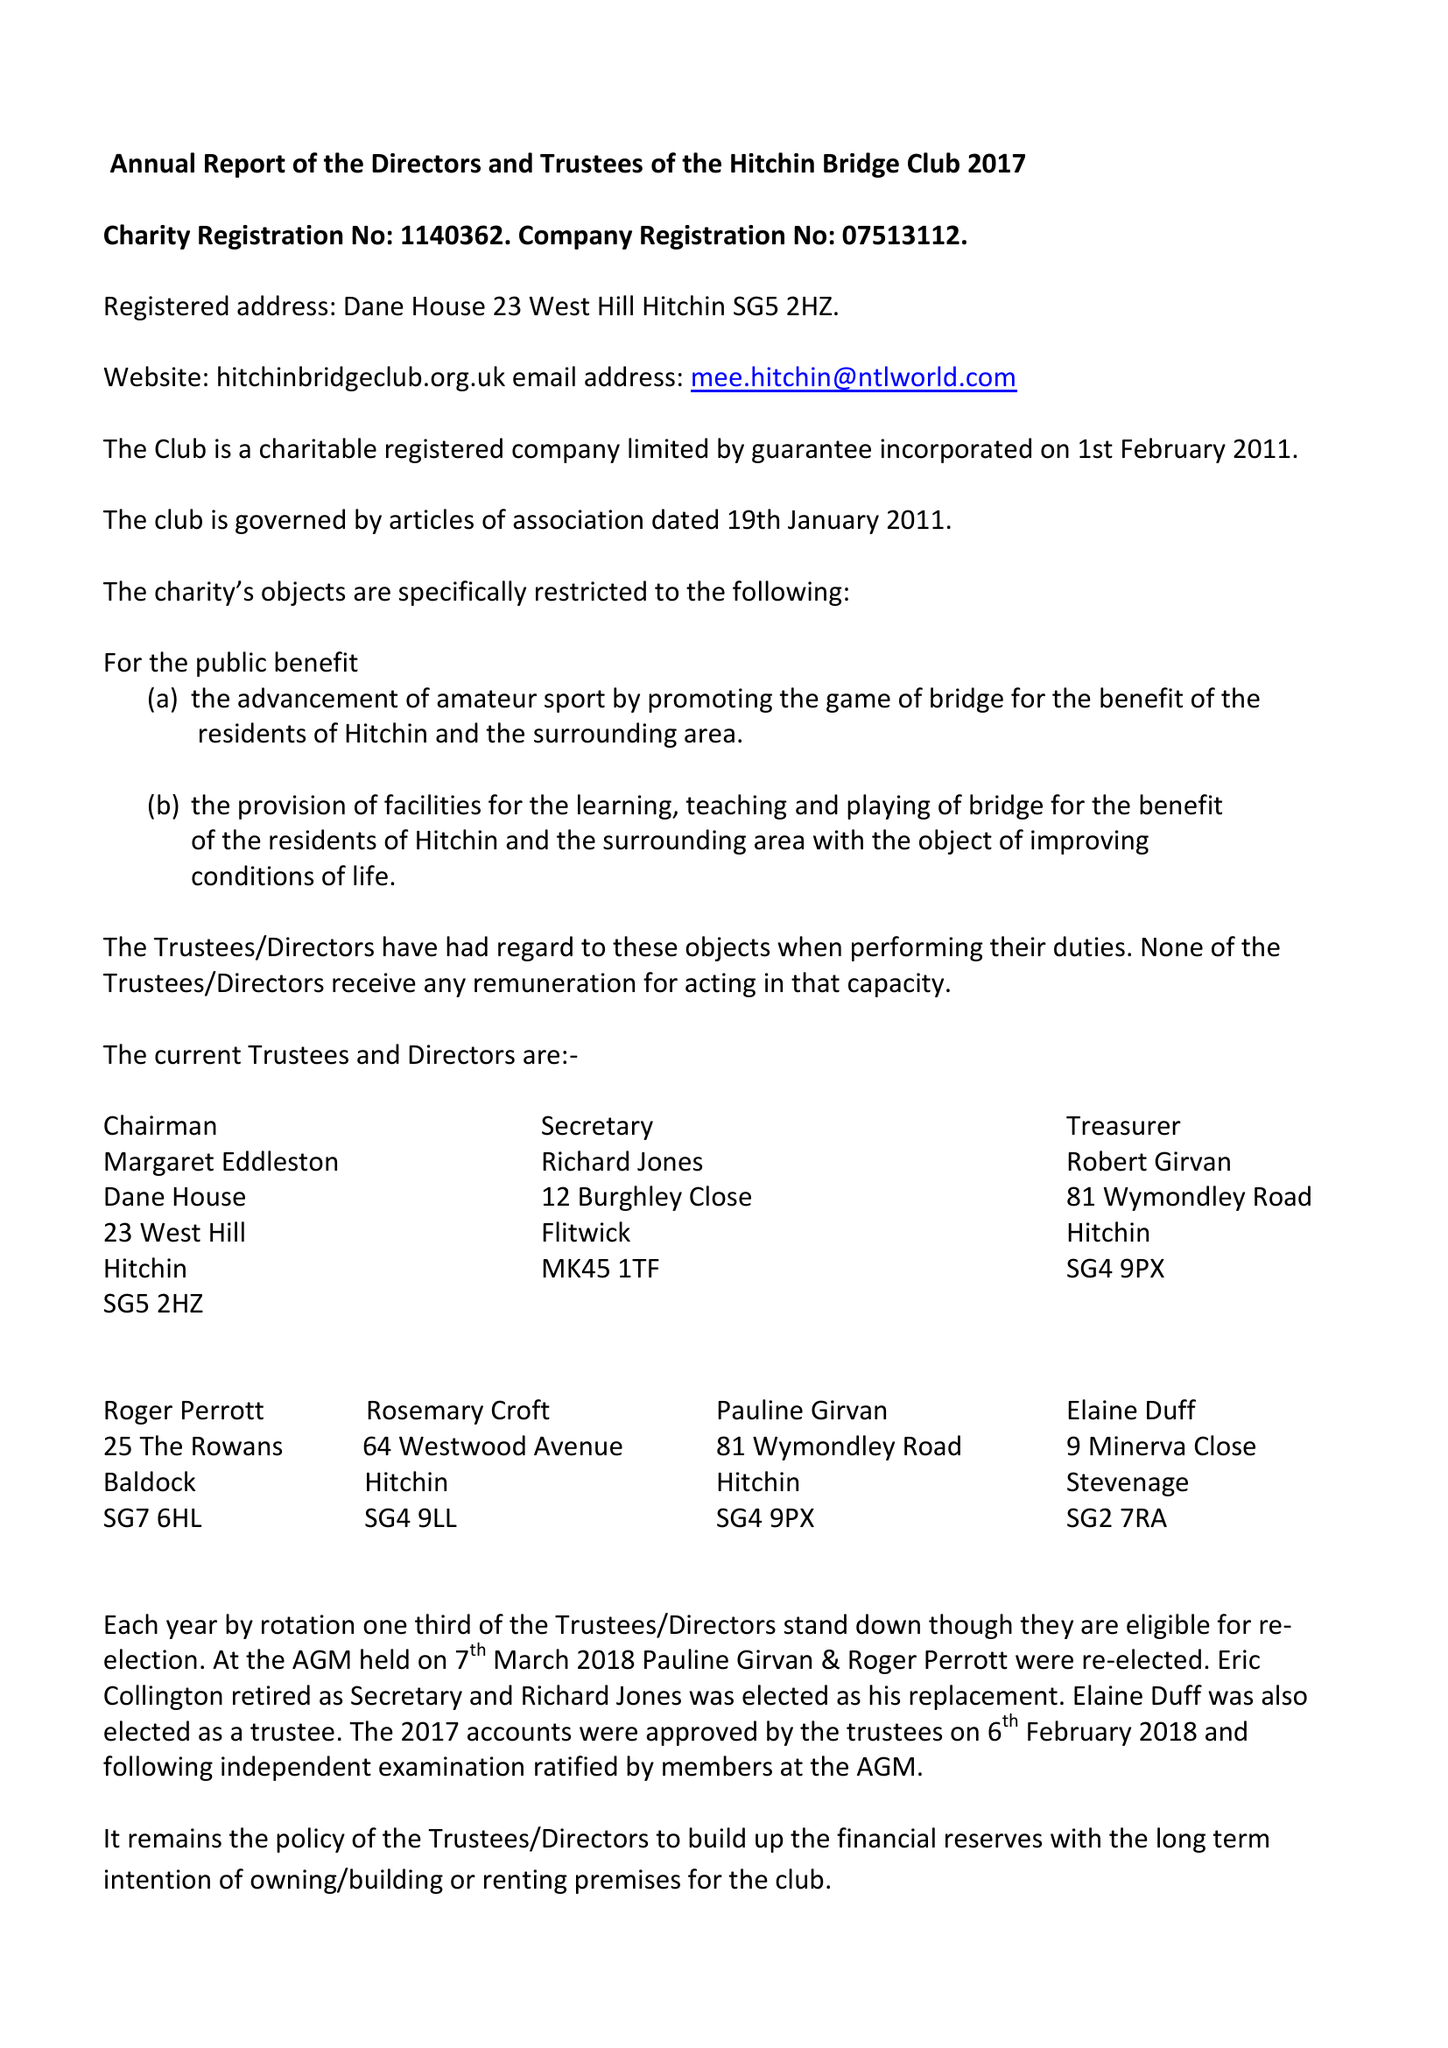What is the value for the report_date?
Answer the question using a single word or phrase. 2017-12-31 